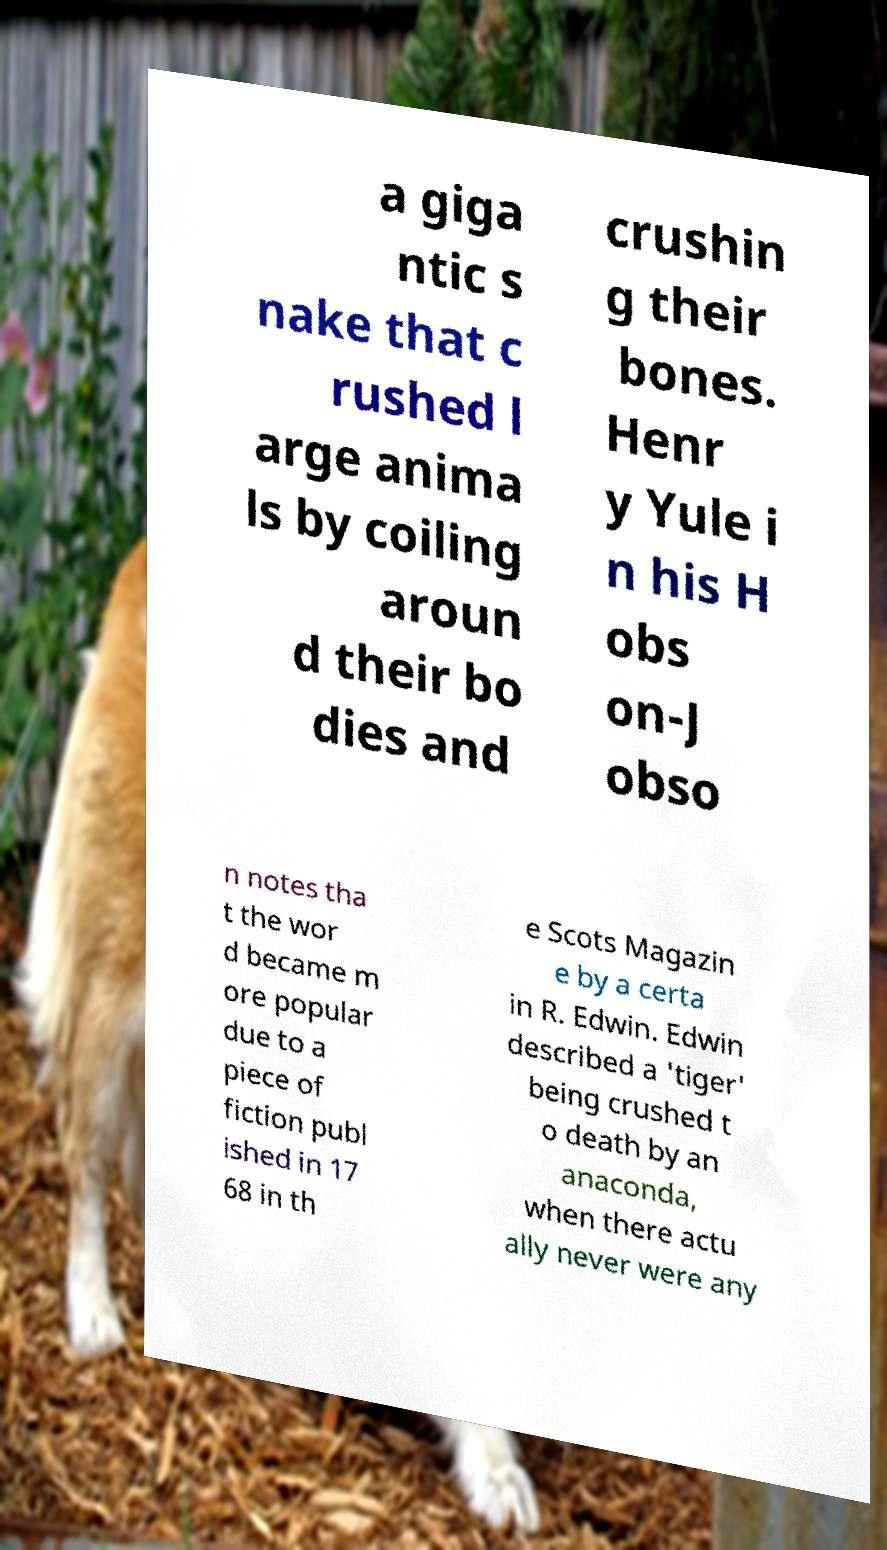For documentation purposes, I need the text within this image transcribed. Could you provide that? a giga ntic s nake that c rushed l arge anima ls by coiling aroun d their bo dies and crushin g their bones. Henr y Yule i n his H obs on-J obso n notes tha t the wor d became m ore popular due to a piece of fiction publ ished in 17 68 in th e Scots Magazin e by a certa in R. Edwin. Edwin described a 'tiger' being crushed t o death by an anaconda, when there actu ally never were any 